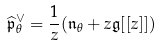<formula> <loc_0><loc_0><loc_500><loc_500>\widehat { \mathfrak { p } } _ { \theta } ^ { \vee } = \frac { 1 } { z } ( \mathfrak { n } _ { \theta } + z \mathfrak { g } [ [ z ] ] )</formula> 